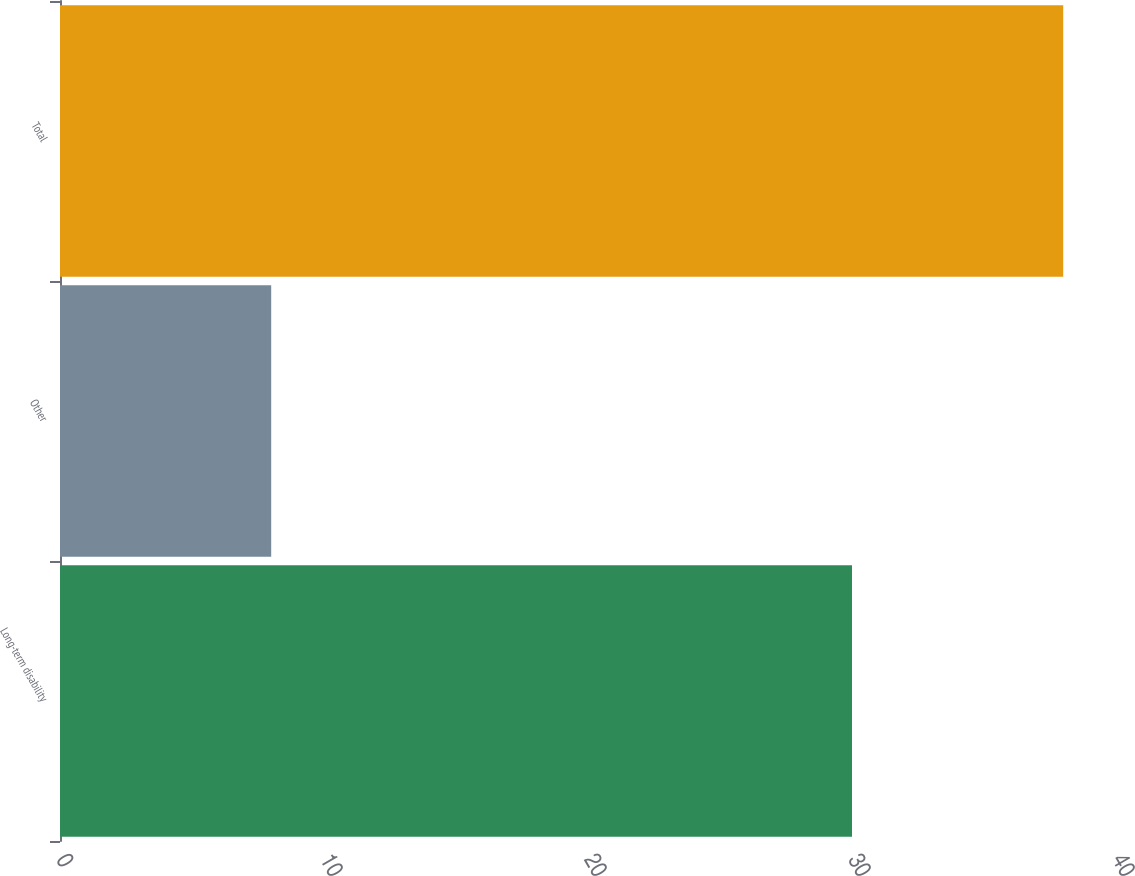Convert chart. <chart><loc_0><loc_0><loc_500><loc_500><bar_chart><fcel>Long-term disability<fcel>Other<fcel>Total<nl><fcel>30<fcel>8<fcel>38<nl></chart> 